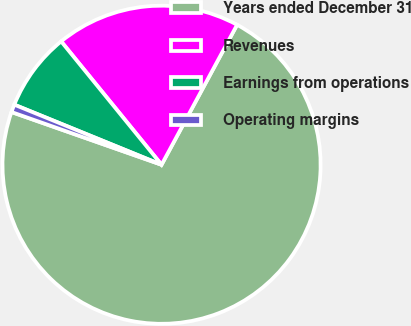Convert chart to OTSL. <chart><loc_0><loc_0><loc_500><loc_500><pie_chart><fcel>Years ended December 31<fcel>Revenues<fcel>Earnings from operations<fcel>Operating margins<nl><fcel>72.5%<fcel>18.75%<fcel>7.96%<fcel>0.79%<nl></chart> 